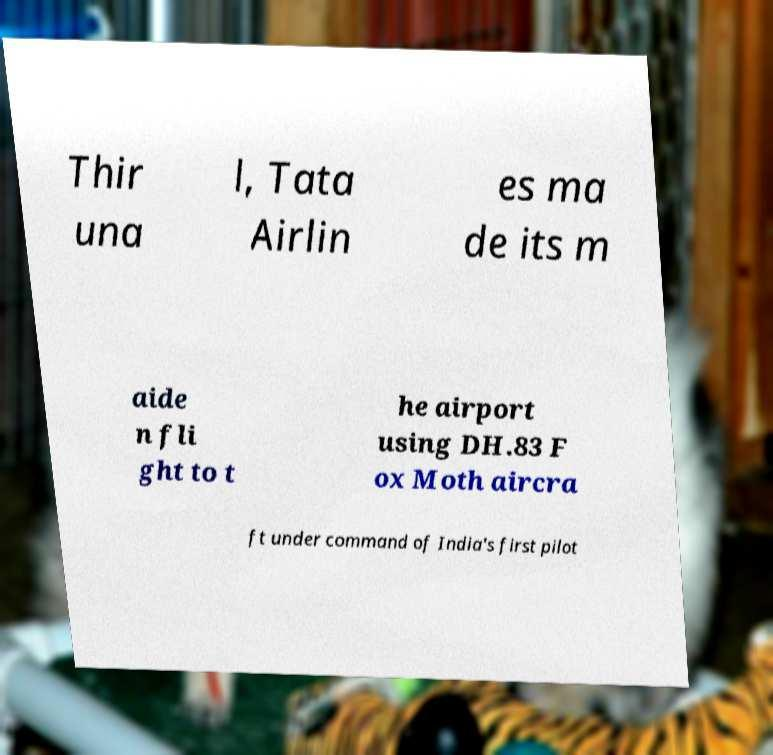What messages or text are displayed in this image? I need them in a readable, typed format. Thir una l, Tata Airlin es ma de its m aide n fli ght to t he airport using DH.83 F ox Moth aircra ft under command of India's first pilot 